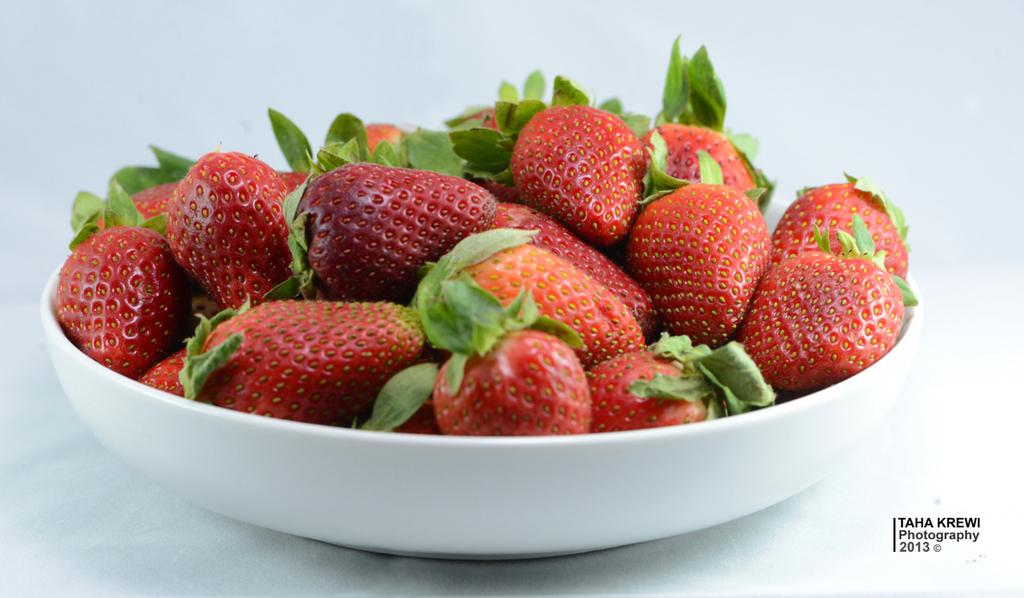What type of fruit is present in the image? There are red color strawberries in the image. What is the color of the plate that holds the strawberries? The strawberries are in a white color plate. Where is the text located in the image? The text is in black color on the right side of the image. What type of bag is visible in the image? There is no bag present in the image. How old is the baby in the image? There is no baby present in the image. 